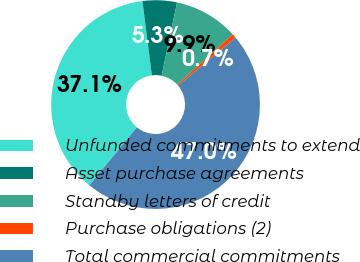<chart> <loc_0><loc_0><loc_500><loc_500><pie_chart><fcel>Unfunded commitments to extend<fcel>Asset purchase agreements<fcel>Standby letters of credit<fcel>Purchase obligations (2)<fcel>Total commercial commitments<nl><fcel>37.07%<fcel>5.31%<fcel>9.94%<fcel>0.67%<fcel>47.01%<nl></chart> 